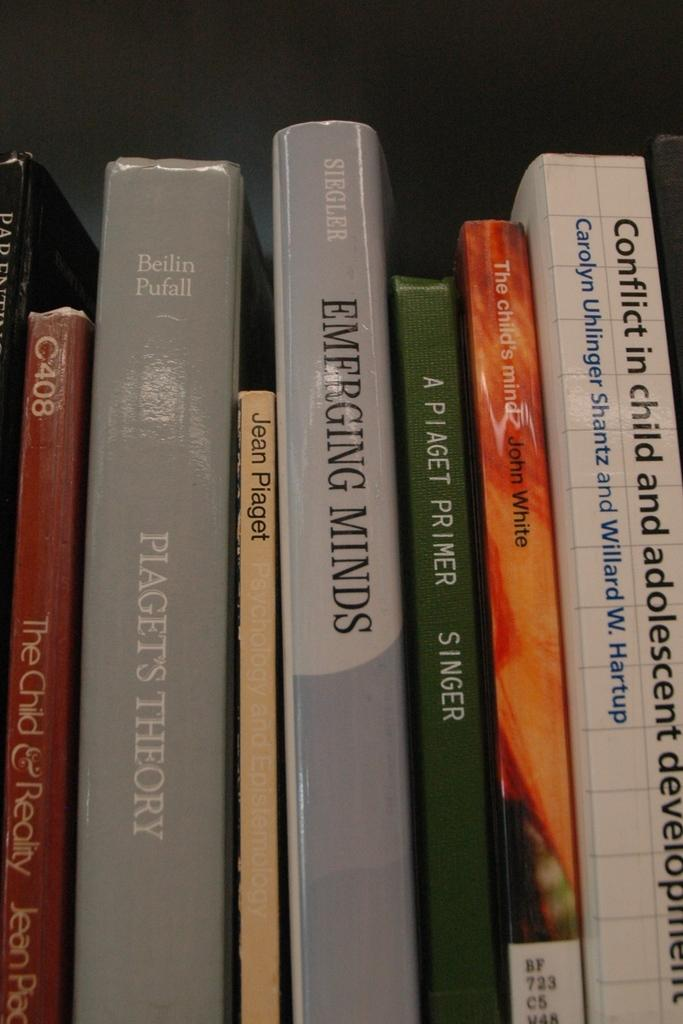How many books are visible in the image? There are eight books in the image. How are the books arranged in the image? The books are arranged in an order. What type of stocking is being used to support the books on the stage in the image? There is no stage or stocking present in the image; it only features eight books arranged in an order. 